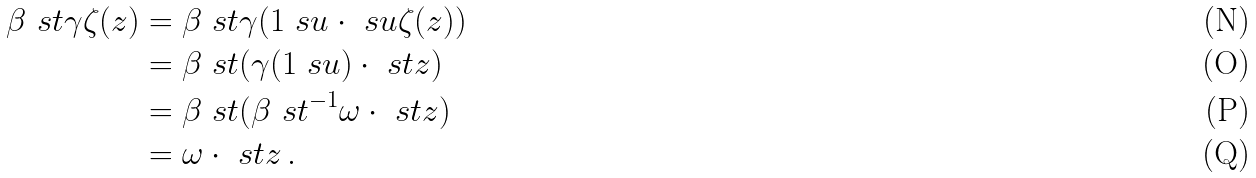Convert formula to latex. <formula><loc_0><loc_0><loc_500><loc_500>\beta \ s t \gamma \zeta ( z ) & = \beta \ s t \gamma ( 1 \ s u \cdot \ s u \zeta ( z ) ) \\ & = \beta \ s t ( \gamma ( 1 \ s u ) \cdot \ s t z ) \\ & = \beta \ s t ( \beta \ s t ^ { - 1 } \omega \cdot \ s t z ) \\ & = \omega \cdot \ s t z \, .</formula> 